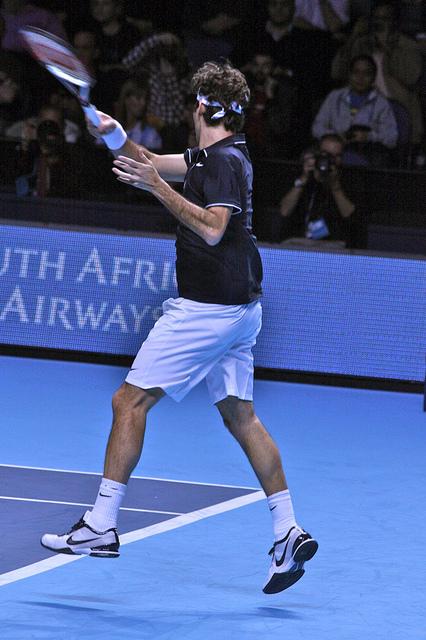What brand of socks is he wearing?
Short answer required. Nike. What is the man in the first row holding to his face?
Short answer required. Camera. What airline is being promoted by the stands?
Keep it brief. South african airways. What color is his shirt?
Give a very brief answer. Black. Does the athlete likes the brand he wears?
Give a very brief answer. Yes. 